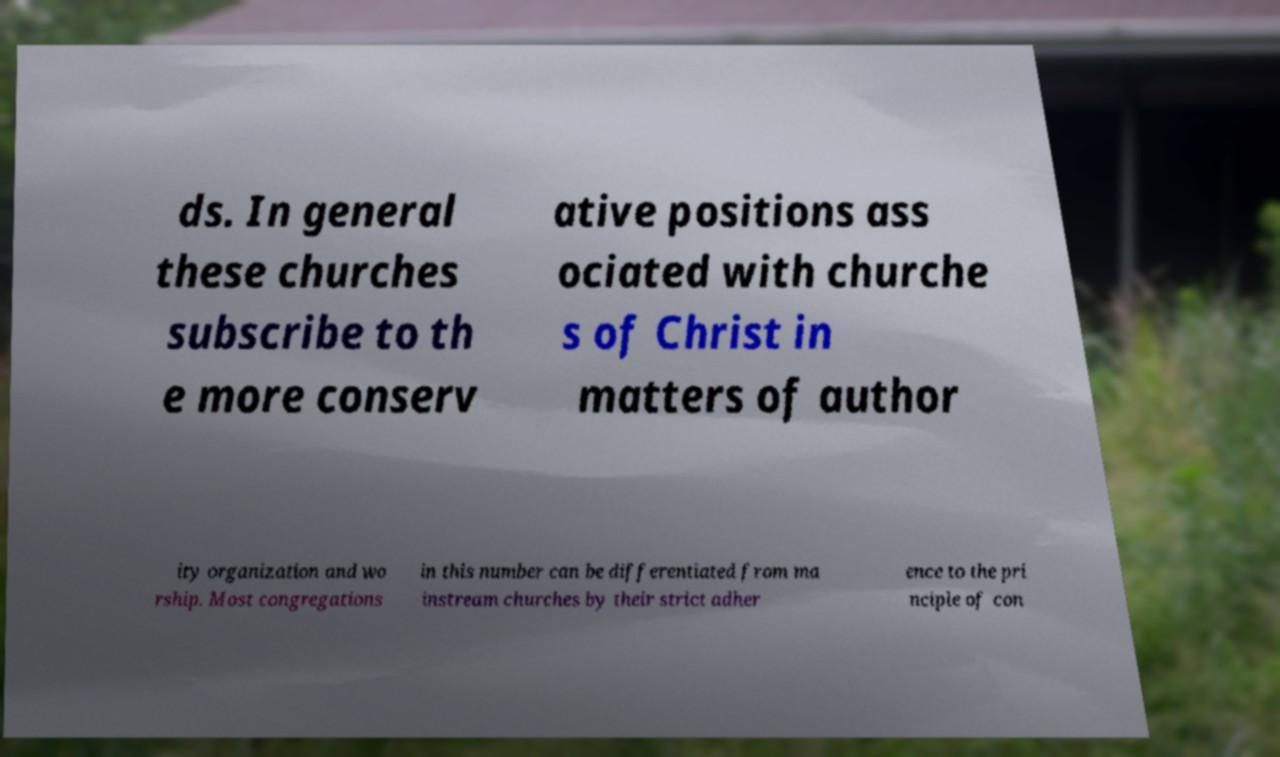There's text embedded in this image that I need extracted. Can you transcribe it verbatim? ds. In general these churches subscribe to th e more conserv ative positions ass ociated with churche s of Christ in matters of author ity organization and wo rship. Most congregations in this number can be differentiated from ma instream churches by their strict adher ence to the pri nciple of con 